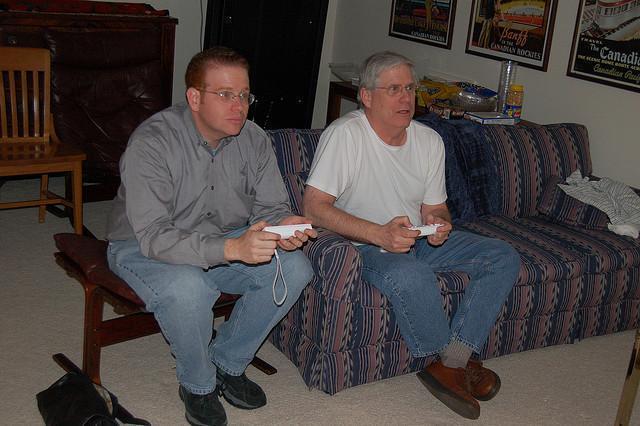What is the name of the white device in the men's hands?
Pick the correct solution from the four options below to address the question.
Options: Game controller, calculator, tv remote, phone. Game controller. 